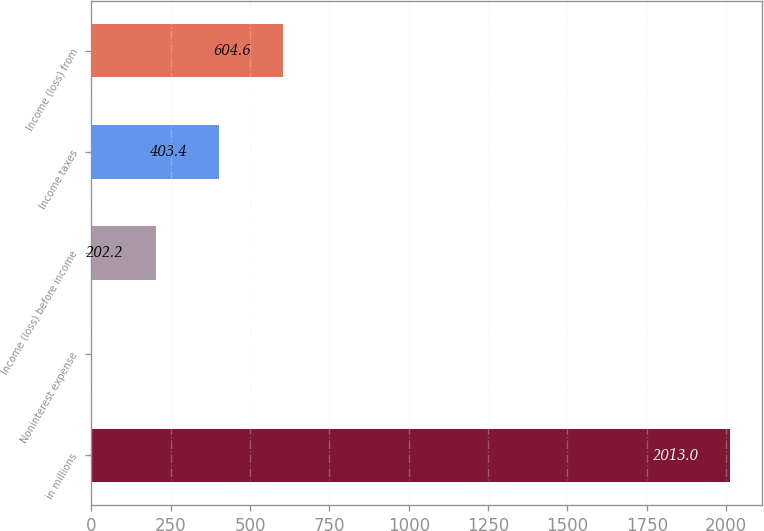Convert chart to OTSL. <chart><loc_0><loc_0><loc_500><loc_500><bar_chart><fcel>in millions<fcel>Noninterest expense<fcel>Income (loss) before income<fcel>Income taxes<fcel>Income (loss) from<nl><fcel>2013<fcel>1<fcel>202.2<fcel>403.4<fcel>604.6<nl></chart> 